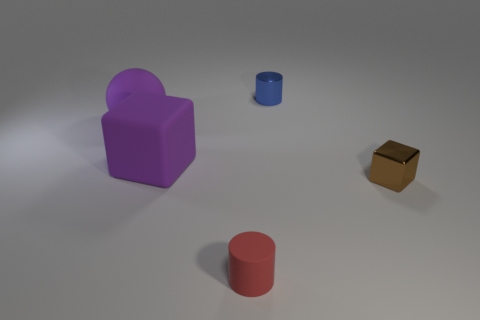What number of objects are either tiny red matte cylinders or cyan cylinders?
Offer a terse response. 1. Is there a thing that has the same size as the purple sphere?
Your answer should be compact. Yes. The brown thing is what shape?
Provide a succinct answer. Cube. Is the number of metallic objects in front of the small blue metal cylinder greater than the number of large rubber things that are in front of the small brown object?
Your response must be concise. Yes. There is a cube left of the blue metal cylinder; is its color the same as the big rubber thing that is to the left of the matte cube?
Offer a very short reply. Yes. There is a object that is the same size as the purple rubber cube; what is its shape?
Make the answer very short. Sphere. Are there any small purple rubber objects of the same shape as the red object?
Your answer should be compact. No. Is the material of the small cylinder that is right of the small red matte thing the same as the small object that is in front of the brown metal object?
Keep it short and to the point. No. There is a object that is the same color as the large cube; what shape is it?
Your response must be concise. Sphere. What number of small objects have the same material as the tiny cube?
Your response must be concise. 1. 